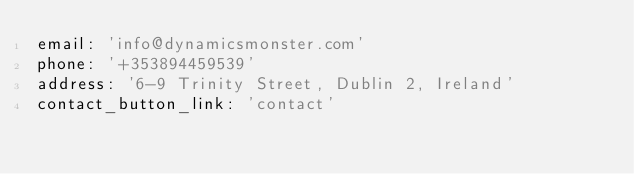<code> <loc_0><loc_0><loc_500><loc_500><_YAML_>email: 'info@dynamicsmonster.com'
phone: '+353894459539'
address: '6-9 Trinity Street, Dublin 2, Ireland'
contact_button_link: 'contact'
</code> 